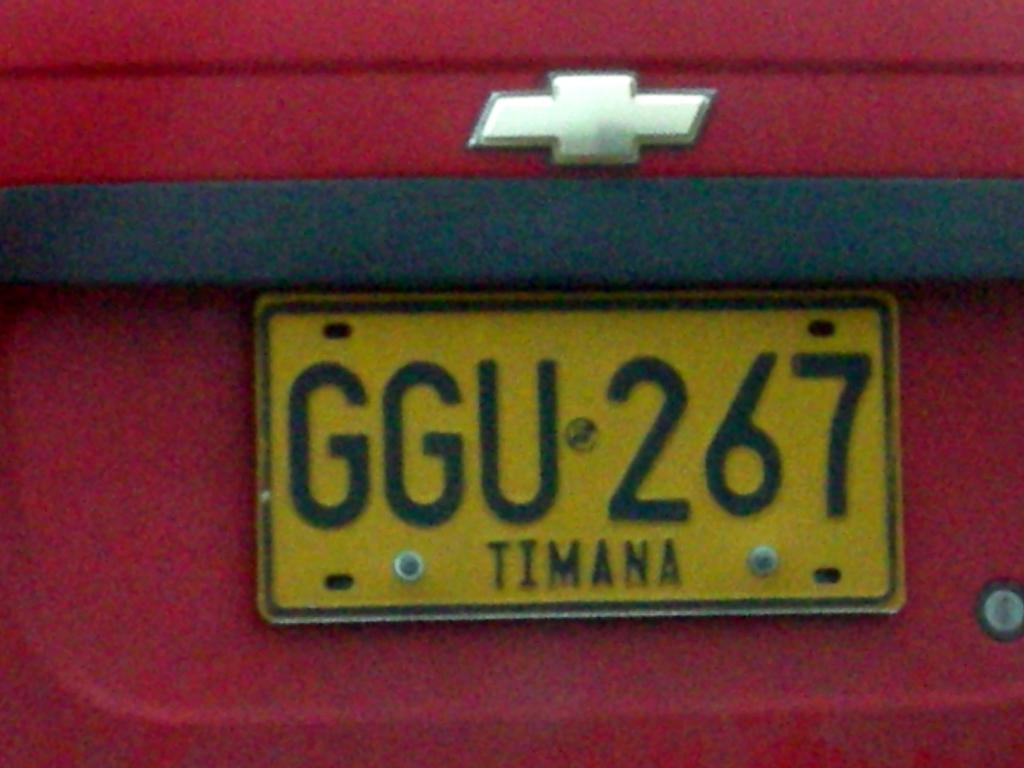What is on the licence plate?
Offer a very short reply. Ggu 267. 